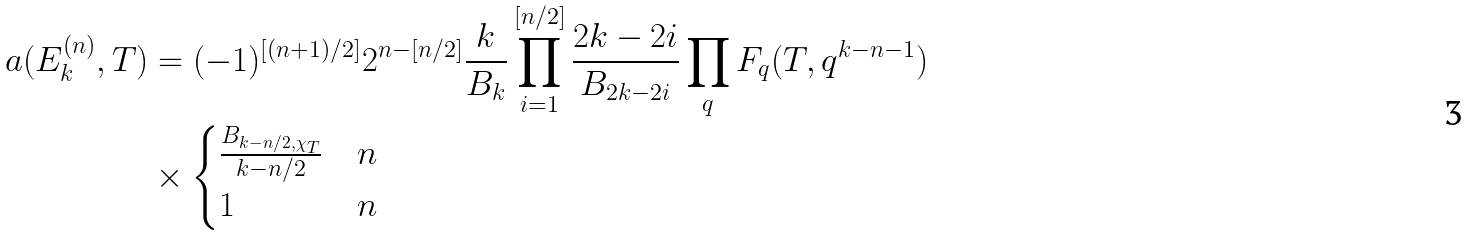<formula> <loc_0><loc_0><loc_500><loc_500>a ( E _ { k } ^ { ( n ) } , T ) & = ( - 1 ) ^ { [ ( n + 1 ) / 2 ] } 2 ^ { n - [ n / 2 ] } \frac { k } { B _ { k } } \prod _ { i = 1 } ^ { [ n / 2 ] } \frac { 2 k - 2 i } { B _ { 2 k - 2 i } } \prod _ { q } F _ { q } ( T , q ^ { k - n - 1 } ) \\ & \times \begin{cases} \frac { B _ { k - n / 2 , \chi _ { T } } } { k - n / 2 } & n \\ 1 & n \end{cases}</formula> 